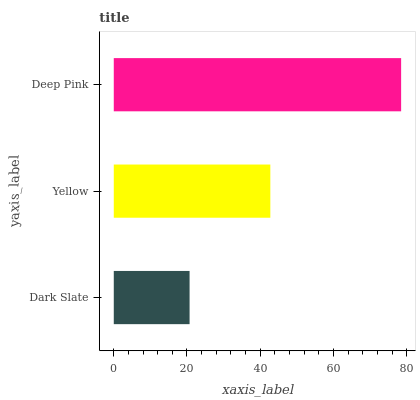Is Dark Slate the minimum?
Answer yes or no. Yes. Is Deep Pink the maximum?
Answer yes or no. Yes. Is Yellow the minimum?
Answer yes or no. No. Is Yellow the maximum?
Answer yes or no. No. Is Yellow greater than Dark Slate?
Answer yes or no. Yes. Is Dark Slate less than Yellow?
Answer yes or no. Yes. Is Dark Slate greater than Yellow?
Answer yes or no. No. Is Yellow less than Dark Slate?
Answer yes or no. No. Is Yellow the high median?
Answer yes or no. Yes. Is Yellow the low median?
Answer yes or no. Yes. Is Deep Pink the high median?
Answer yes or no. No. Is Deep Pink the low median?
Answer yes or no. No. 